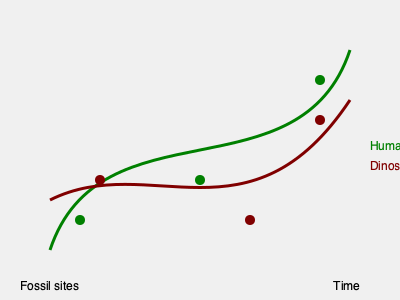Based on the fossil evidence shown in the map, what can be inferred about the migration patterns of humans and dinosaurs over time? To interpret the migration patterns from the fossil evidence, we need to follow these steps:

1. Identify the axes:
   - The x-axis represents time, moving from left (earlier) to right (later).
   - The y-axis represents geographical location (not specified, but implied).

2. Analyze the human migration pattern (green line):
   - Starts at the bottom left, indicating earlier time and a specific location.
   - Moves upward and to the right, suggesting movement to new areas over time.
   - Ends at the top right, implying the most recent human fossil evidence.

3. Analyze the dinosaur migration pattern (brown line):
   - Begins slightly higher than the human line on the left, suggesting a different starting location.
   - Follows a different path, sometimes intersecting with the human line.
   - Ends higher than its starting point, but not as high as the human line.

4. Compare the two patterns:
   - Both show general movement upward and to the right, indicating migration over time.
   - The paths cross, suggesting potential interactions or shared habitats at certain points.
   - The human line ends higher, possibly indicating more extensive migration or survival in diverse environments.

5. Interpret the fossil sites (circles):
   - Green circles on the human line and brown on the dinosaur line represent fossil evidence.
   - The distribution of these sites supports the overall migration patterns.

6. Draw conclusions:
   - Humans and dinosaurs appear to have migrated through similar areas but at different rates and with different patterns.
   - The evidence suggests a longer or more extensive migration for humans compared to dinosaurs.
   - There are periods where human and dinosaur habitats may have overlapped, based on the crossing paths.
Answer: Humans and dinosaurs migrated through overlapping areas at different rates, with humans showing more extensive movement over time. 